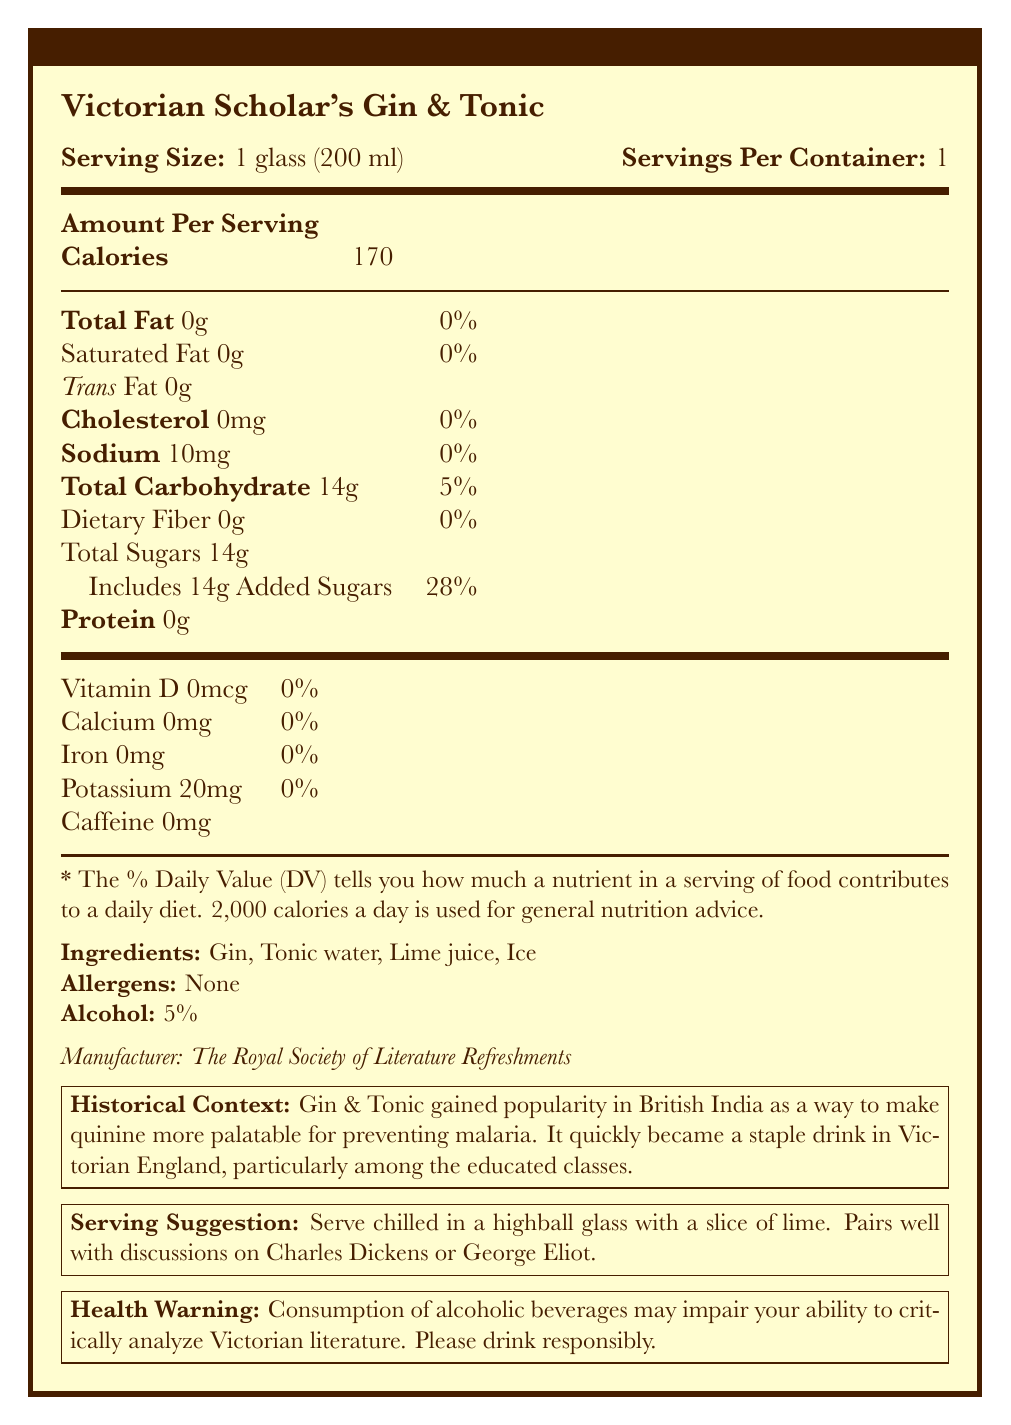what is the serving size of the Victorian Scholar's Gin & Tonic? The serving size is explicitly listed as "1 glass (200 ml)" in the document.
Answer: 1 glass (200 ml) how many calories are in one serving? The document states that the calories in one serving are 170.
Answer: 170 how much sodium does the Victorian Scholar's Gin & Tonic contain? The sodium content per serving is specified as 10mg.
Answer: 10mg what is the total carbohydrate content in one serving? The document shows that the total carbohydrate content is 14g per serving.
Answer: 14g what are the ingredients listed for the Victorian Scholar's Gin & Tonic? The ingredients are clearly listed as Gin, Tonic water, Lime juice, and Ice.
Answer: Gin, Tonic water, Lime juice, Ice what percentage of added sugars is in one serving? A. 10% B. 20% C. 28% The document indicates that added sugars make up 28% of the daily value per serving.
Answer: C which nutrient has the highest percentage of daily value per serving in the Victorian Scholar's Gin & Tonic? A. Total Fat B. Sodium C. Added Sugars The added sugars make up 28% of the daily value per serving, which is the highest among the listed nutrients.
Answer: C does the Victorian Scholar's Gin & Tonic contain any protein? The document states that the protein content is 0g.
Answer: No is caffeine present in the Victorian Scholar's Gin & Tonic? The document specifies that the caffeine content is 0mg.
Answer: No can this beverage be considered a good source of potassium? The document shows that the potassium content is only 20mg, which is not a significant amount to be considered a good source.
Answer: No summarize the nutritional and historical context provided in the document. The document provides detailed nutritional information about the Victorian Scholar's Gin & Tonic, including its macronutrient content, serving size, and historical context. It highlights the beverage's popularity among academics in Victorian England and offers warnings and serving suggestions.
Answer: The Victorian Scholar's Gin & Tonic is a 170-calorie beverage with 14g of sugars and 10mg of sodium per serving. It is 5% alcohol and contains no fat, protein, or significant vitamins and minerals. This drink, needing to be chilled and served with lime, gained popularity in British India for making quinine more palatable to combat malaria and became a staple among Victorian academics. Consumption might impede critical literary analysis. what is the recommended serving suggestion for this beverage? The document recommends serving the beverage chilled in a highball glass with a slice of lime and suggests that it pairs well with discussions on Charles Dickens or George Eliot.
Answer: Serve chilled in a highball glass with a slice of lime. Pairs well with discussions on Charles Dickens or George Eliot. how does the Victorian Scholar's Gin & Tonic compare to its modern equivalent in terms of caloric content? The document states that the modern equivalent has 30 calories less than the Victorian Scholar's Gin & Tonic.
Answer: -30 calories who is the manufacturer of the Victorian Scholar's Gin & Tonic? The manufacturer is listed as The Royal Society of Literature Refreshments.
Answer: The Royal Society of Literature Refreshments what potential effect does the document mention regarding the consumption of this beverage? The document warns that consuming the beverage may impair one's ability to critically analyze Victorian literature.
Answer: Consumption of alcoholic beverages may impair your ability to critically analyze Victorian literature. how many servings are there in one container? The document indicates that there is one serving per container.
Answer: 1 is there any vitamin D present in the Victorian Scholar's Gin & Tonic? The vitamin D content is listed as 0mcg.
Answer: No what minerals are present in the beverage, albeit in negligible amounts? The document lists Calcium (0mg), Iron (0mg), and Potassium (20mg) as the minerals present in the beverage.
Answer: Calcium, Iron, Potassium who were the particular consumers of this beverage in Victorian times according to the historical context? The document states that Gin & Tonic became a staple drink particularly among the educated classes in Victorian England.
Answer: The educated classes is the beverage allergen-free? The document lists "None" under allergens, indicating it is allergen-free.
Answer: Yes is the gin in the beverage sourced from a specific distillery? The document does not provide information about the specific sourcing of the gin used in the beverage.
Answer: Not enough information 